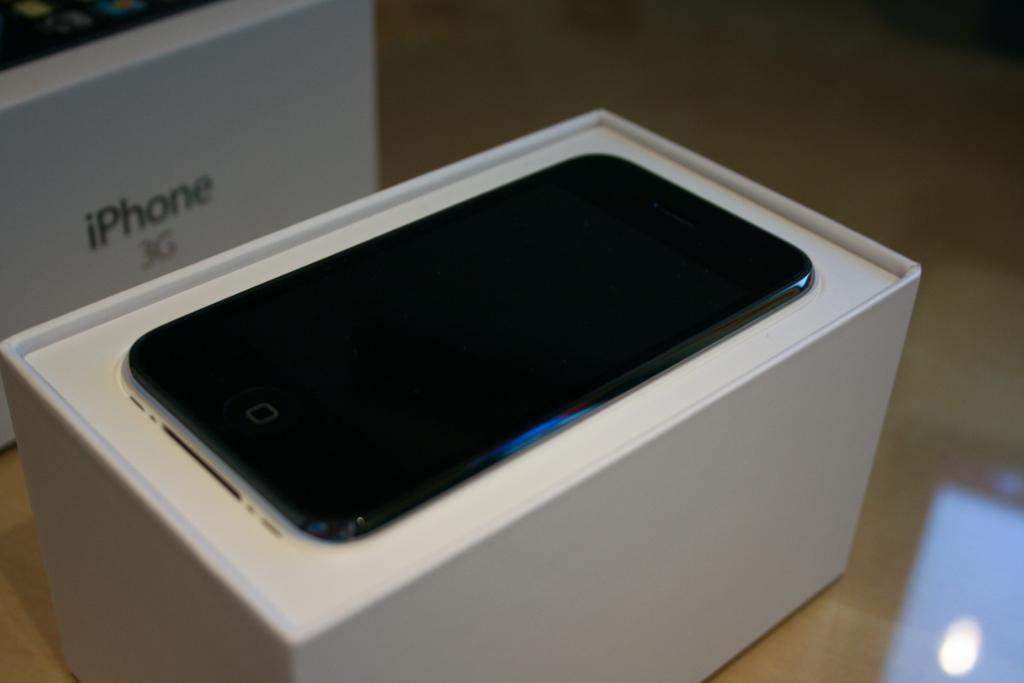What type of phone is this?
Your response must be concise. Iphone. 